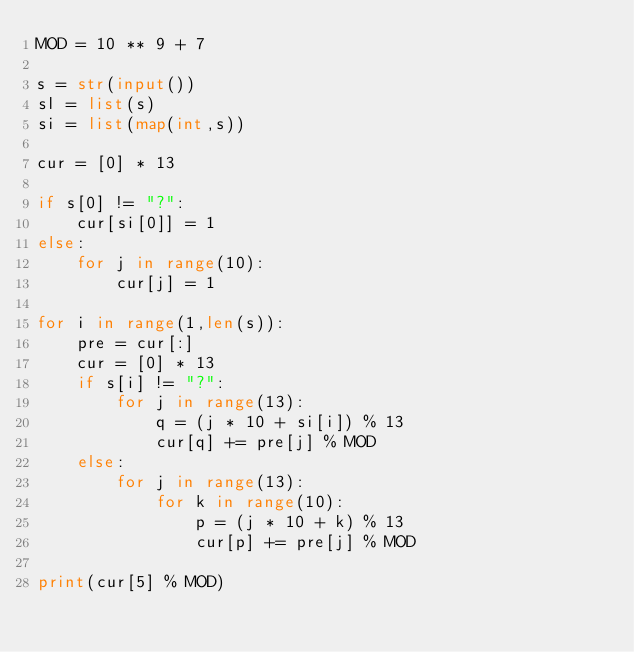Convert code to text. <code><loc_0><loc_0><loc_500><loc_500><_Python_>MOD = 10 ** 9 + 7

s = str(input())
sl = list(s)
si = list(map(int,s))

cur = [0] * 13

if s[0] != "?":
    cur[si[0]] = 1
else:
    for j in range(10):
        cur[j] = 1

for i in range(1,len(s)):
    pre = cur[:]
    cur = [0] * 13
    if s[i] != "?":
        for j in range(13):
            q = (j * 10 + si[i]) % 13
            cur[q] += pre[j] % MOD
    else:
        for j in range(13):
            for k in range(10):
                p = (j * 10 + k) % 13
                cur[p] += pre[j] % MOD

print(cur[5] % MOD)</code> 